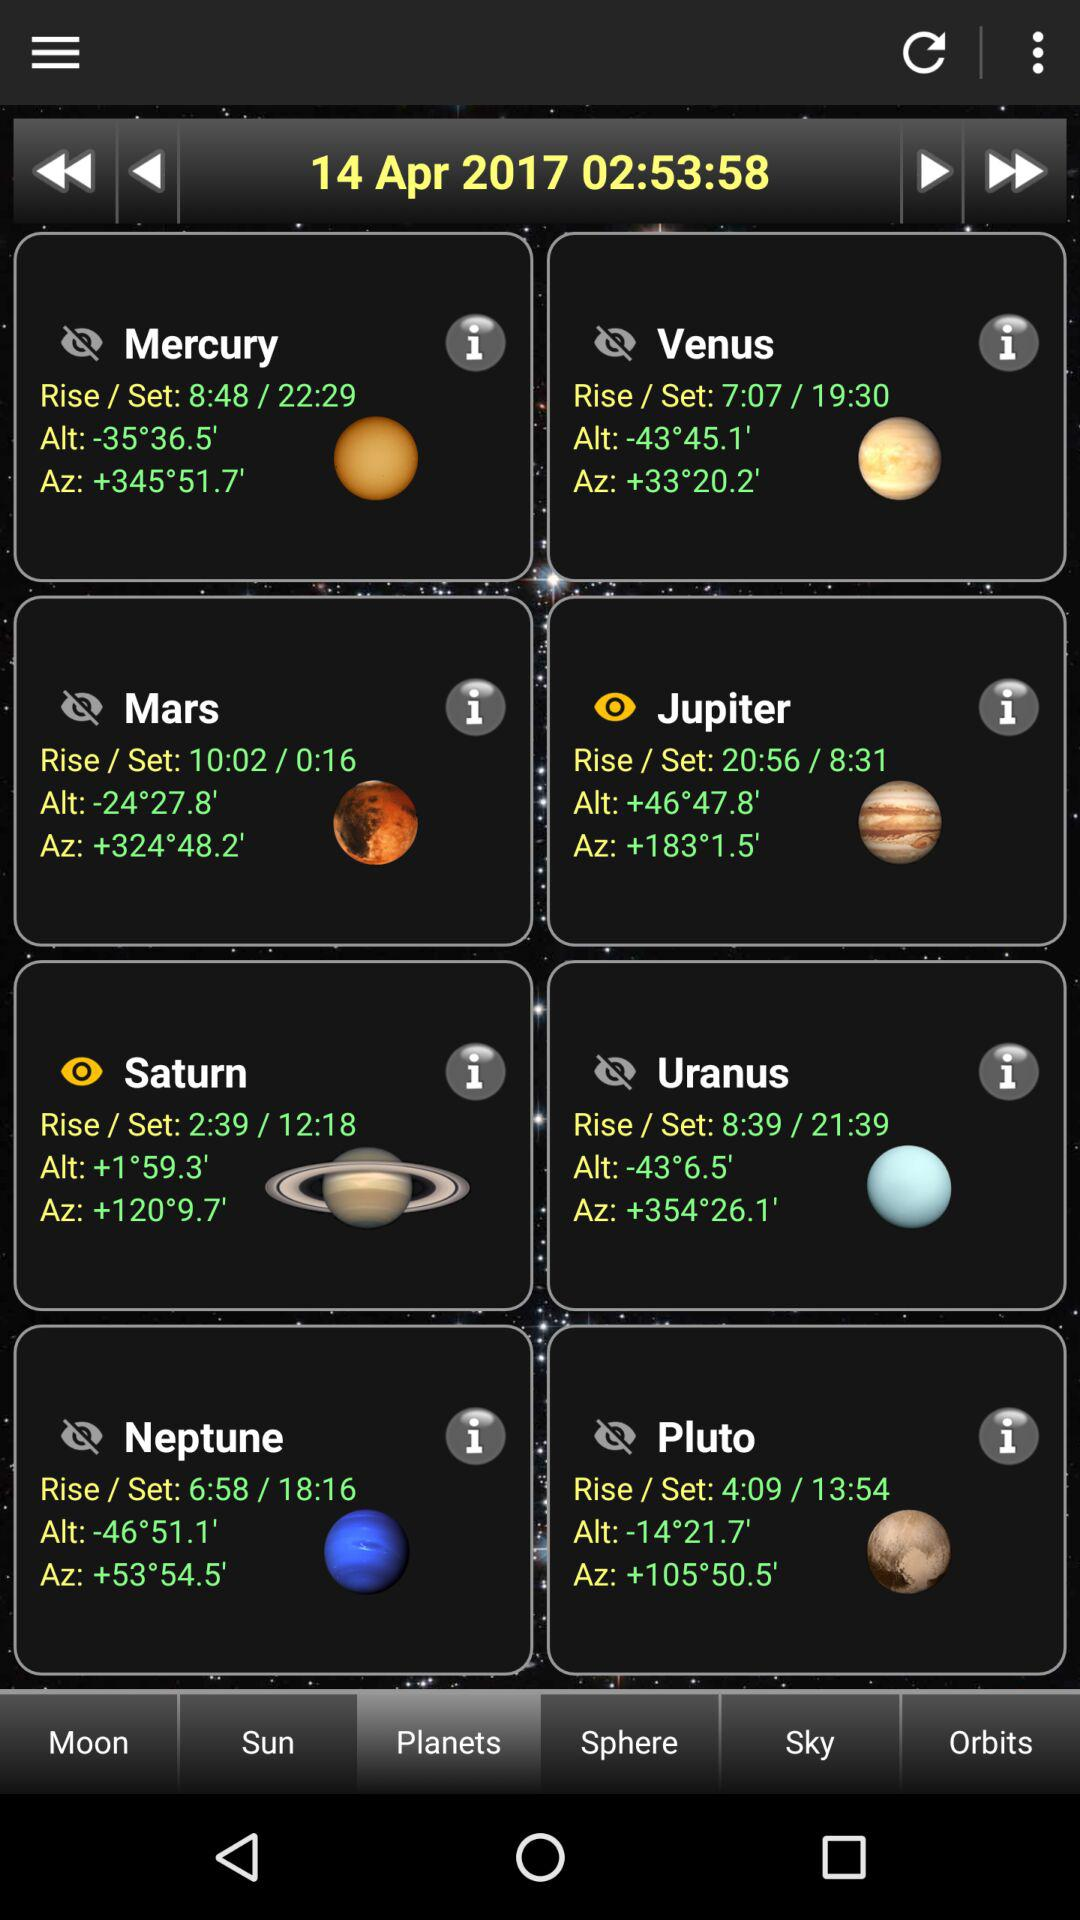How many planets are in the solar system?
Answer the question using a single word or phrase. 8 